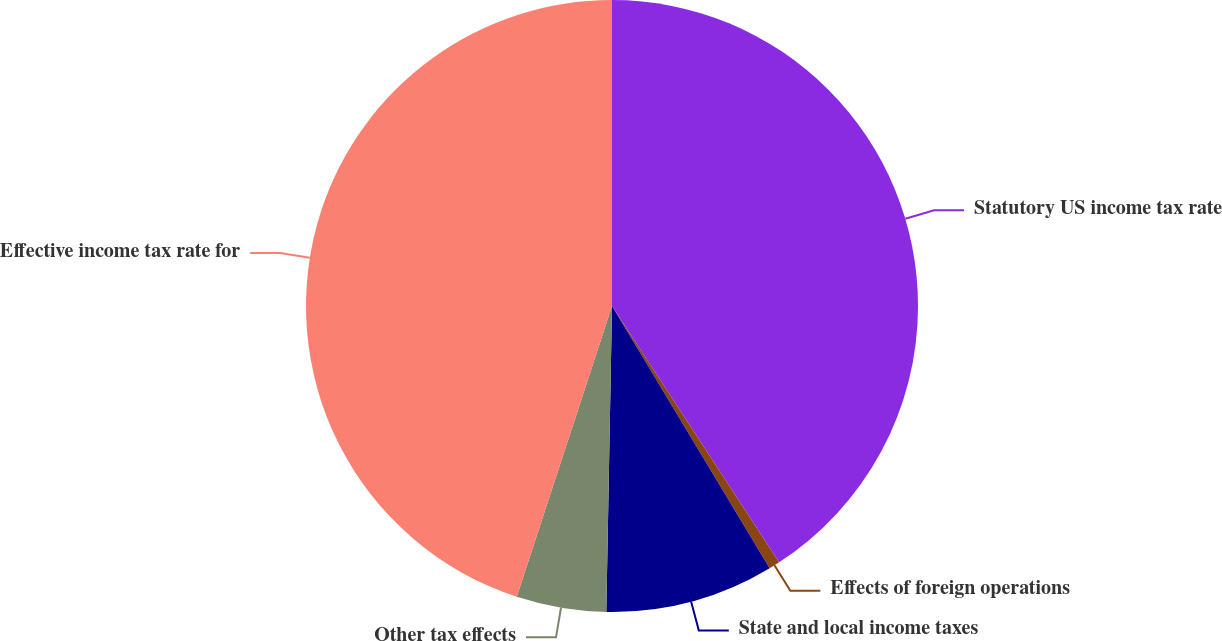Convert chart to OTSL. <chart><loc_0><loc_0><loc_500><loc_500><pie_chart><fcel>Statutory US income tax rate<fcel>Effects of foreign operations<fcel>State and local income taxes<fcel>Other tax effects<fcel>Effective income tax rate for<nl><fcel>40.8%<fcel>0.58%<fcel>8.91%<fcel>4.74%<fcel>44.96%<nl></chart> 